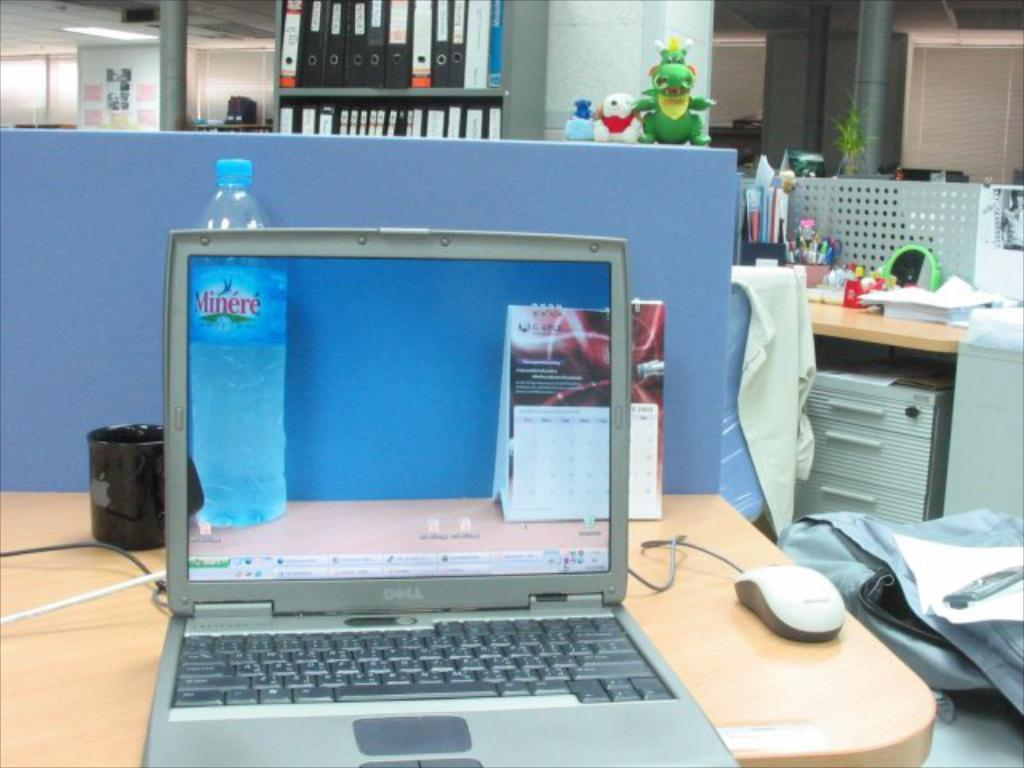<image>
Write a terse but informative summary of the picture. A laptop screen shows a bottle of Minere water. 